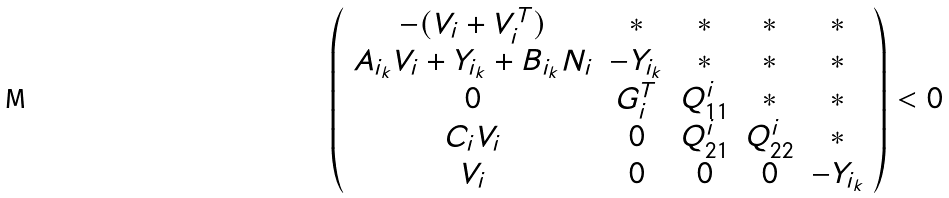Convert formula to latex. <formula><loc_0><loc_0><loc_500><loc_500>\left ( \begin{array} { c c c c c } - ( V _ { i } + V _ { i } ^ { T } ) & * & * & * & * \\ A _ { i _ { k } } V _ { i } + Y _ { i _ { k } } + B _ { i _ { k } } N _ { i } & - Y _ { i _ { k } } & * & * & * \\ 0 & G _ { i } ^ { T } & Q _ { 1 1 } ^ { i } & * & * \\ C _ { i } V _ { i } & 0 & Q _ { 2 1 } ^ { i } & Q _ { 2 2 } ^ { i } & * \\ V _ { i } & 0 & 0 & 0 & - Y _ { i _ { k } } \end{array} \right ) < 0</formula> 